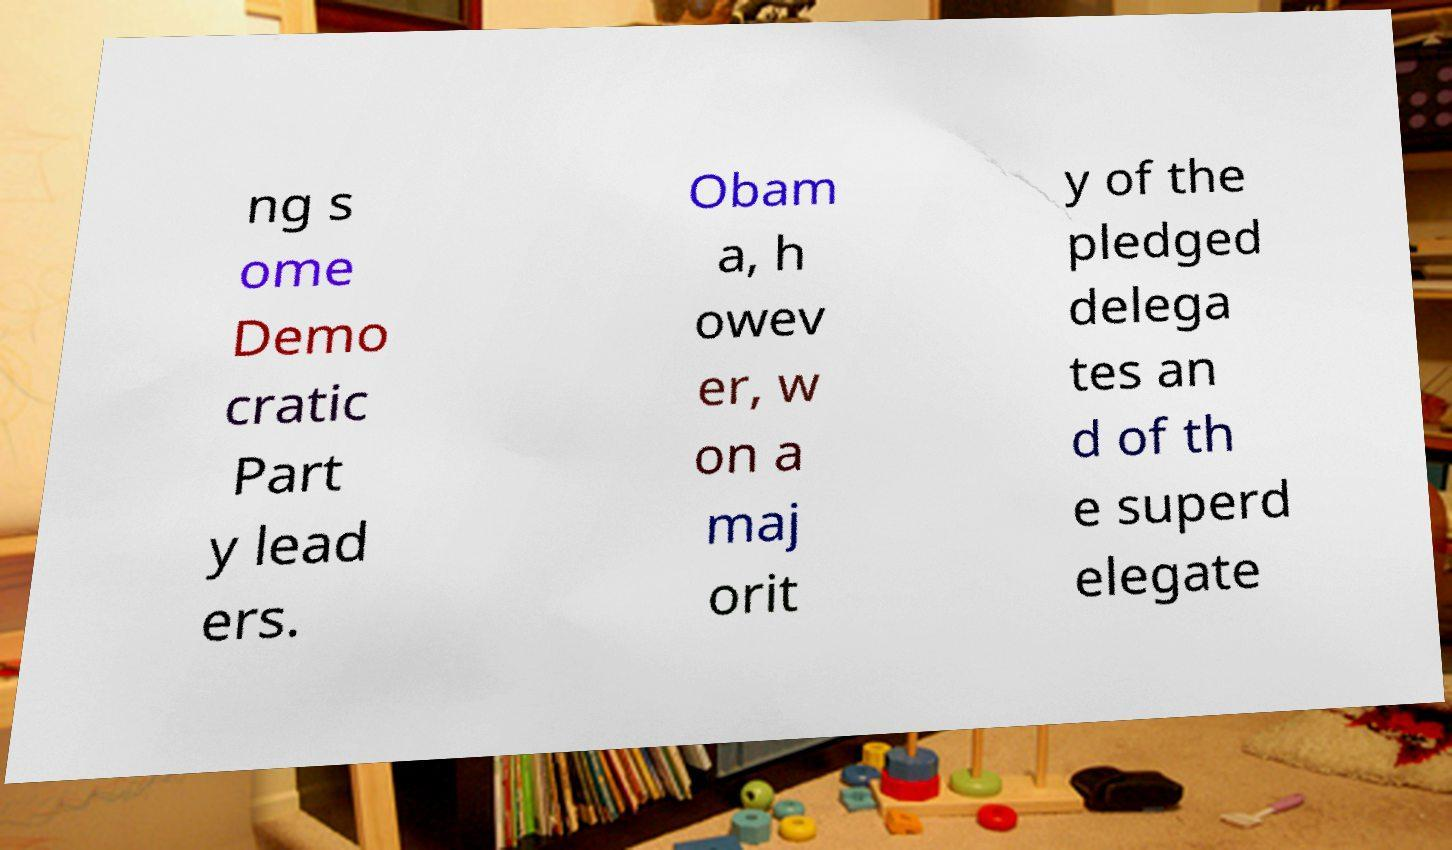For documentation purposes, I need the text within this image transcribed. Could you provide that? ng s ome Demo cratic Part y lead ers. Obam a, h owev er, w on a maj orit y of the pledged delega tes an d of th e superd elegate 